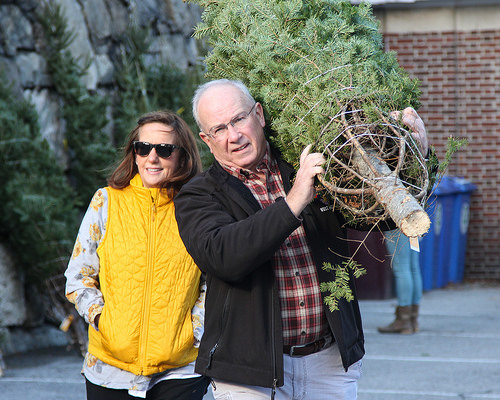<image>
Is the man to the left of the woman? Yes. From this viewpoint, the man is positioned to the left side relative to the woman. Is the tree above the trash can? No. The tree is not positioned above the trash can. The vertical arrangement shows a different relationship. 